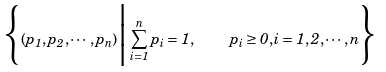Convert formula to latex. <formula><loc_0><loc_0><loc_500><loc_500>\Big \{ ( p _ { 1 } , p _ { 2 } , \cdots , p _ { n } ) \Big | \sum _ { i = 1 } ^ { n } p _ { i } = 1 , \quad p _ { i } \geq 0 , i = 1 , 2 , \cdots , n \Big \}</formula> 